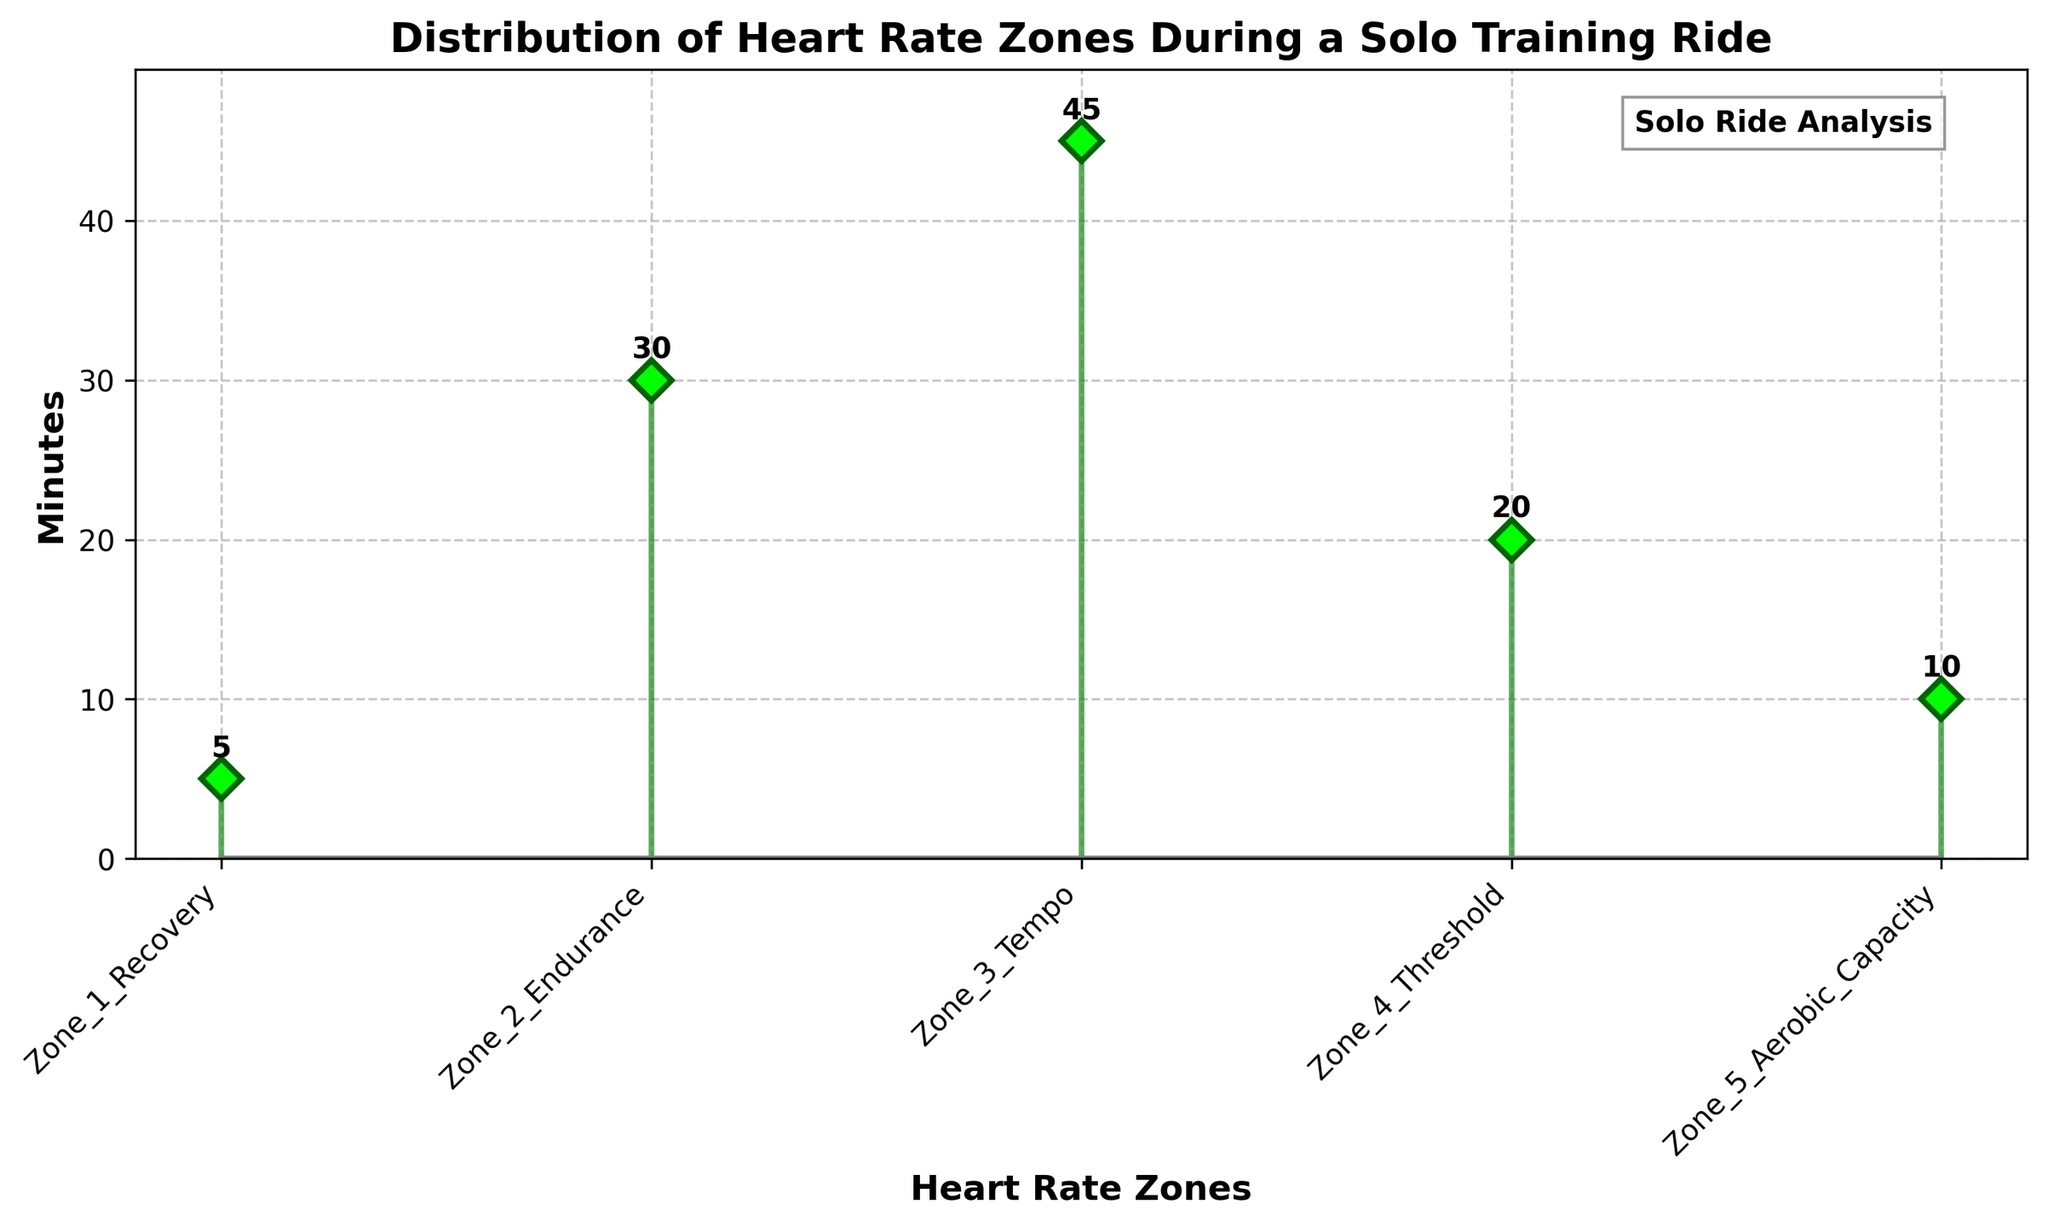what is the title of the figure? The title of the figure is usually displayed at the top and summarizes what the figure is about. Here, it reads "Distribution of Heart Rate Zones During a Solo Training Ride".
Answer: Distribution of Heart Rate Zones During a Solo Training Ride how many heart rate zones are illustrated in the plot? To determine the number of heart rate zones, count the distinct labels on the x-axis. Here, there are five labels indicating five heart rate zones.
Answer: 5 which heart rate zone had the maximum training time? To find the zone with the maximum training time, observe the y-values of the stems and identify which one is the tallest. The tallest stem corresponds to "Zone_3_Tempo".
Answer: Zone_3_Tempo what is the total amount of time spent in Zone 1 and Zone 2? Sum the minutes spent in Zone_1_Recovery and Zone_2_Endurance. These are 5 and 30 minutes respectively, so the total is 5 + 30.
Answer: 35 minutes which heart rate zones have training times less than 20 minutes? Look at the y-values of the stems and identify which ones are less than 20. Both Zone_1_Recovery (5 minutes) and Zone_5_Aerobic_Capacity (10 minutes) fall under this criterion.
Answer: Zone_1_Recovery, Zone_5_Aerobic_Capacity how much more time is spent in Zone 3 than in Zone 4? Subtract the training time of Zone_4_Threshold from that of Zone_3_Tempo. The values are 45 minutes for Zone 3 and 20 minutes for Zone 4. Therefore, 45 - 20.
Answer: 25 minutes what is the average training time across all heart rate zones? To calculate the average, sum all the training times and divide by the number of zones. The times are 5, 30, 45, 20, and 10, which sum up to 110 minutes. Dividing by 5 zones gives 110 / 5.
Answer: 22 minutes which zone had exactly twice the training time spent in Zone 5? The training time in Zone 5 is 10 minutes. Doubling this gives 20 minutes. According to the figure, Zone_4_Threshold has 20 minutes, so it matches.
Answer: Zone_4_Threshold 